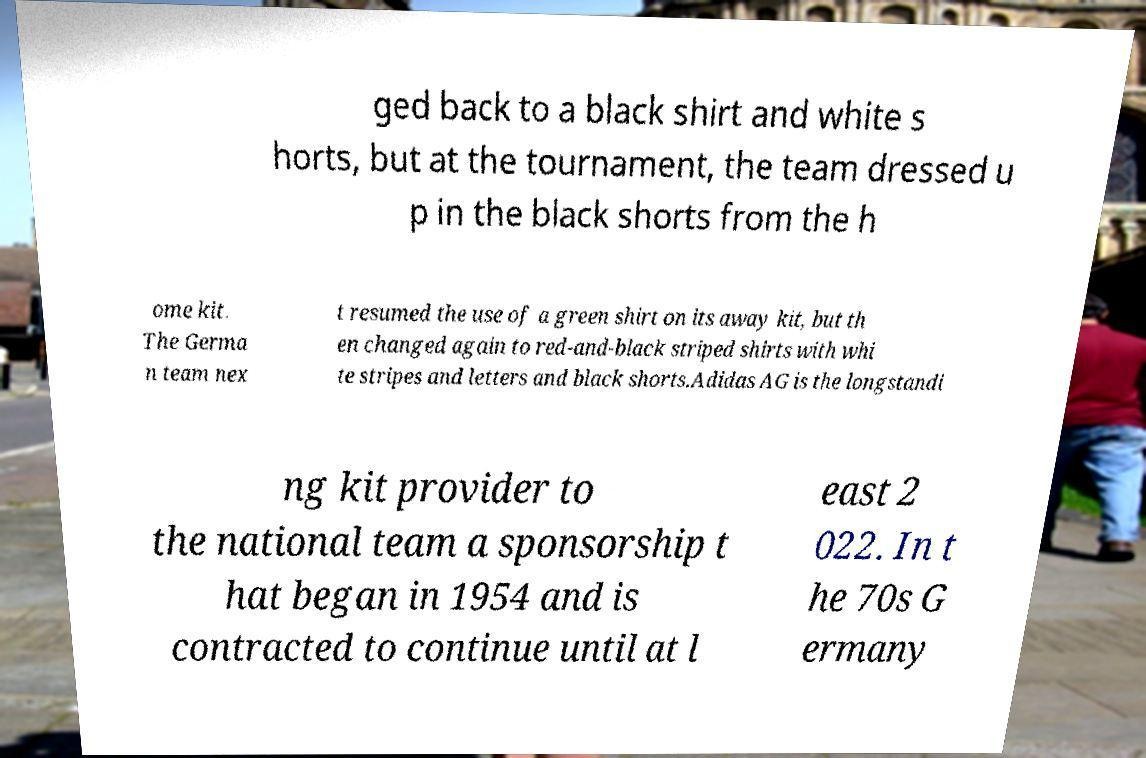Can you read and provide the text displayed in the image?This photo seems to have some interesting text. Can you extract and type it out for me? ged back to a black shirt and white s horts, but at the tournament, the team dressed u p in the black shorts from the h ome kit. The Germa n team nex t resumed the use of a green shirt on its away kit, but th en changed again to red-and-black striped shirts with whi te stripes and letters and black shorts.Adidas AG is the longstandi ng kit provider to the national team a sponsorship t hat began in 1954 and is contracted to continue until at l east 2 022. In t he 70s G ermany 